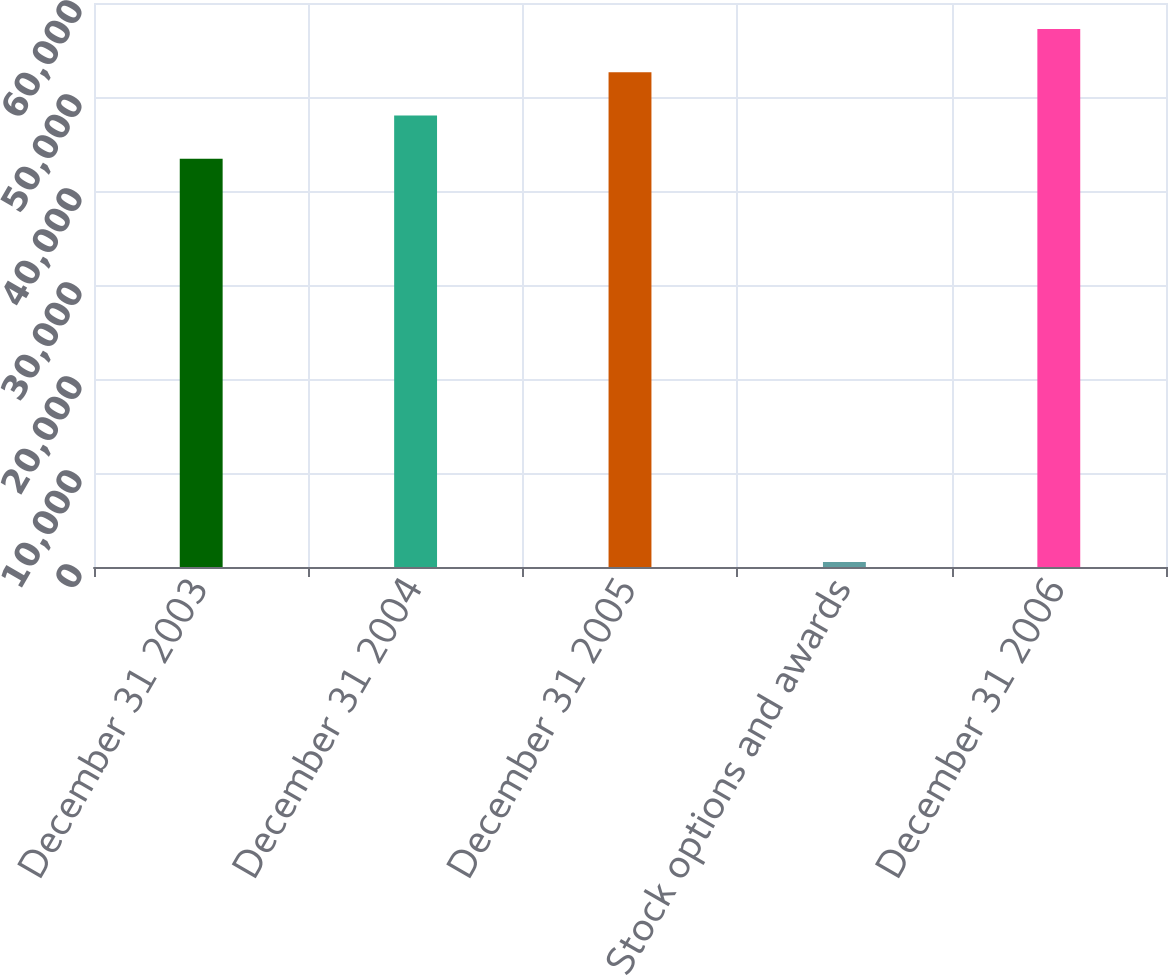Convert chart to OTSL. <chart><loc_0><loc_0><loc_500><loc_500><bar_chart><fcel>December 31 2003<fcel>December 31 2004<fcel>December 31 2005<fcel>Stock options and awards<fcel>December 31 2006<nl><fcel>43435<fcel>48032.3<fcel>52629.6<fcel>523<fcel>57226.9<nl></chart> 